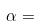<formula> <loc_0><loc_0><loc_500><loc_500>\alpha =</formula> 